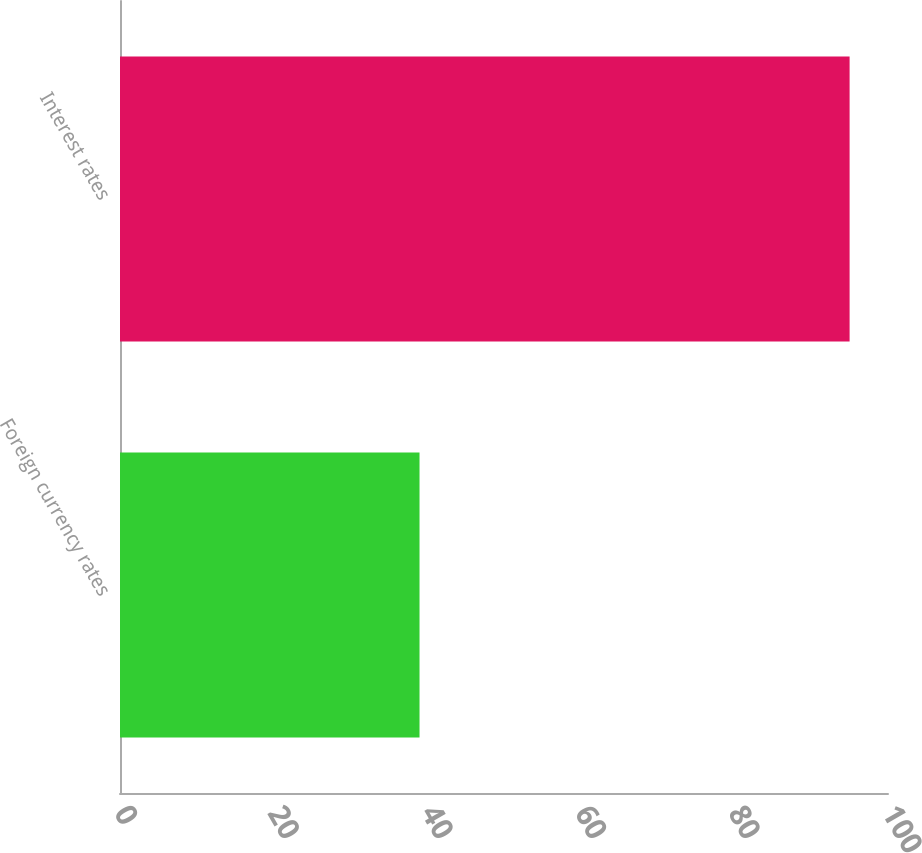<chart> <loc_0><loc_0><loc_500><loc_500><bar_chart><fcel>Foreign currency rates<fcel>Interest rates<nl><fcel>39<fcel>95<nl></chart> 